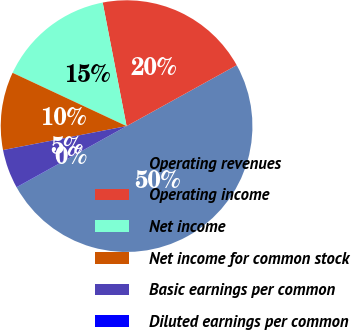Convert chart to OTSL. <chart><loc_0><loc_0><loc_500><loc_500><pie_chart><fcel>Operating revenues<fcel>Operating income<fcel>Net income<fcel>Net income for common stock<fcel>Basic earnings per common<fcel>Diluted earnings per common<nl><fcel>49.97%<fcel>20.0%<fcel>15.0%<fcel>10.01%<fcel>5.01%<fcel>0.02%<nl></chart> 